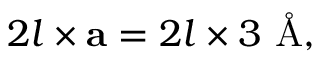<formula> <loc_0><loc_0><loc_500><loc_500>2 l \times a = 2 l \times 3 \AA ,</formula> 